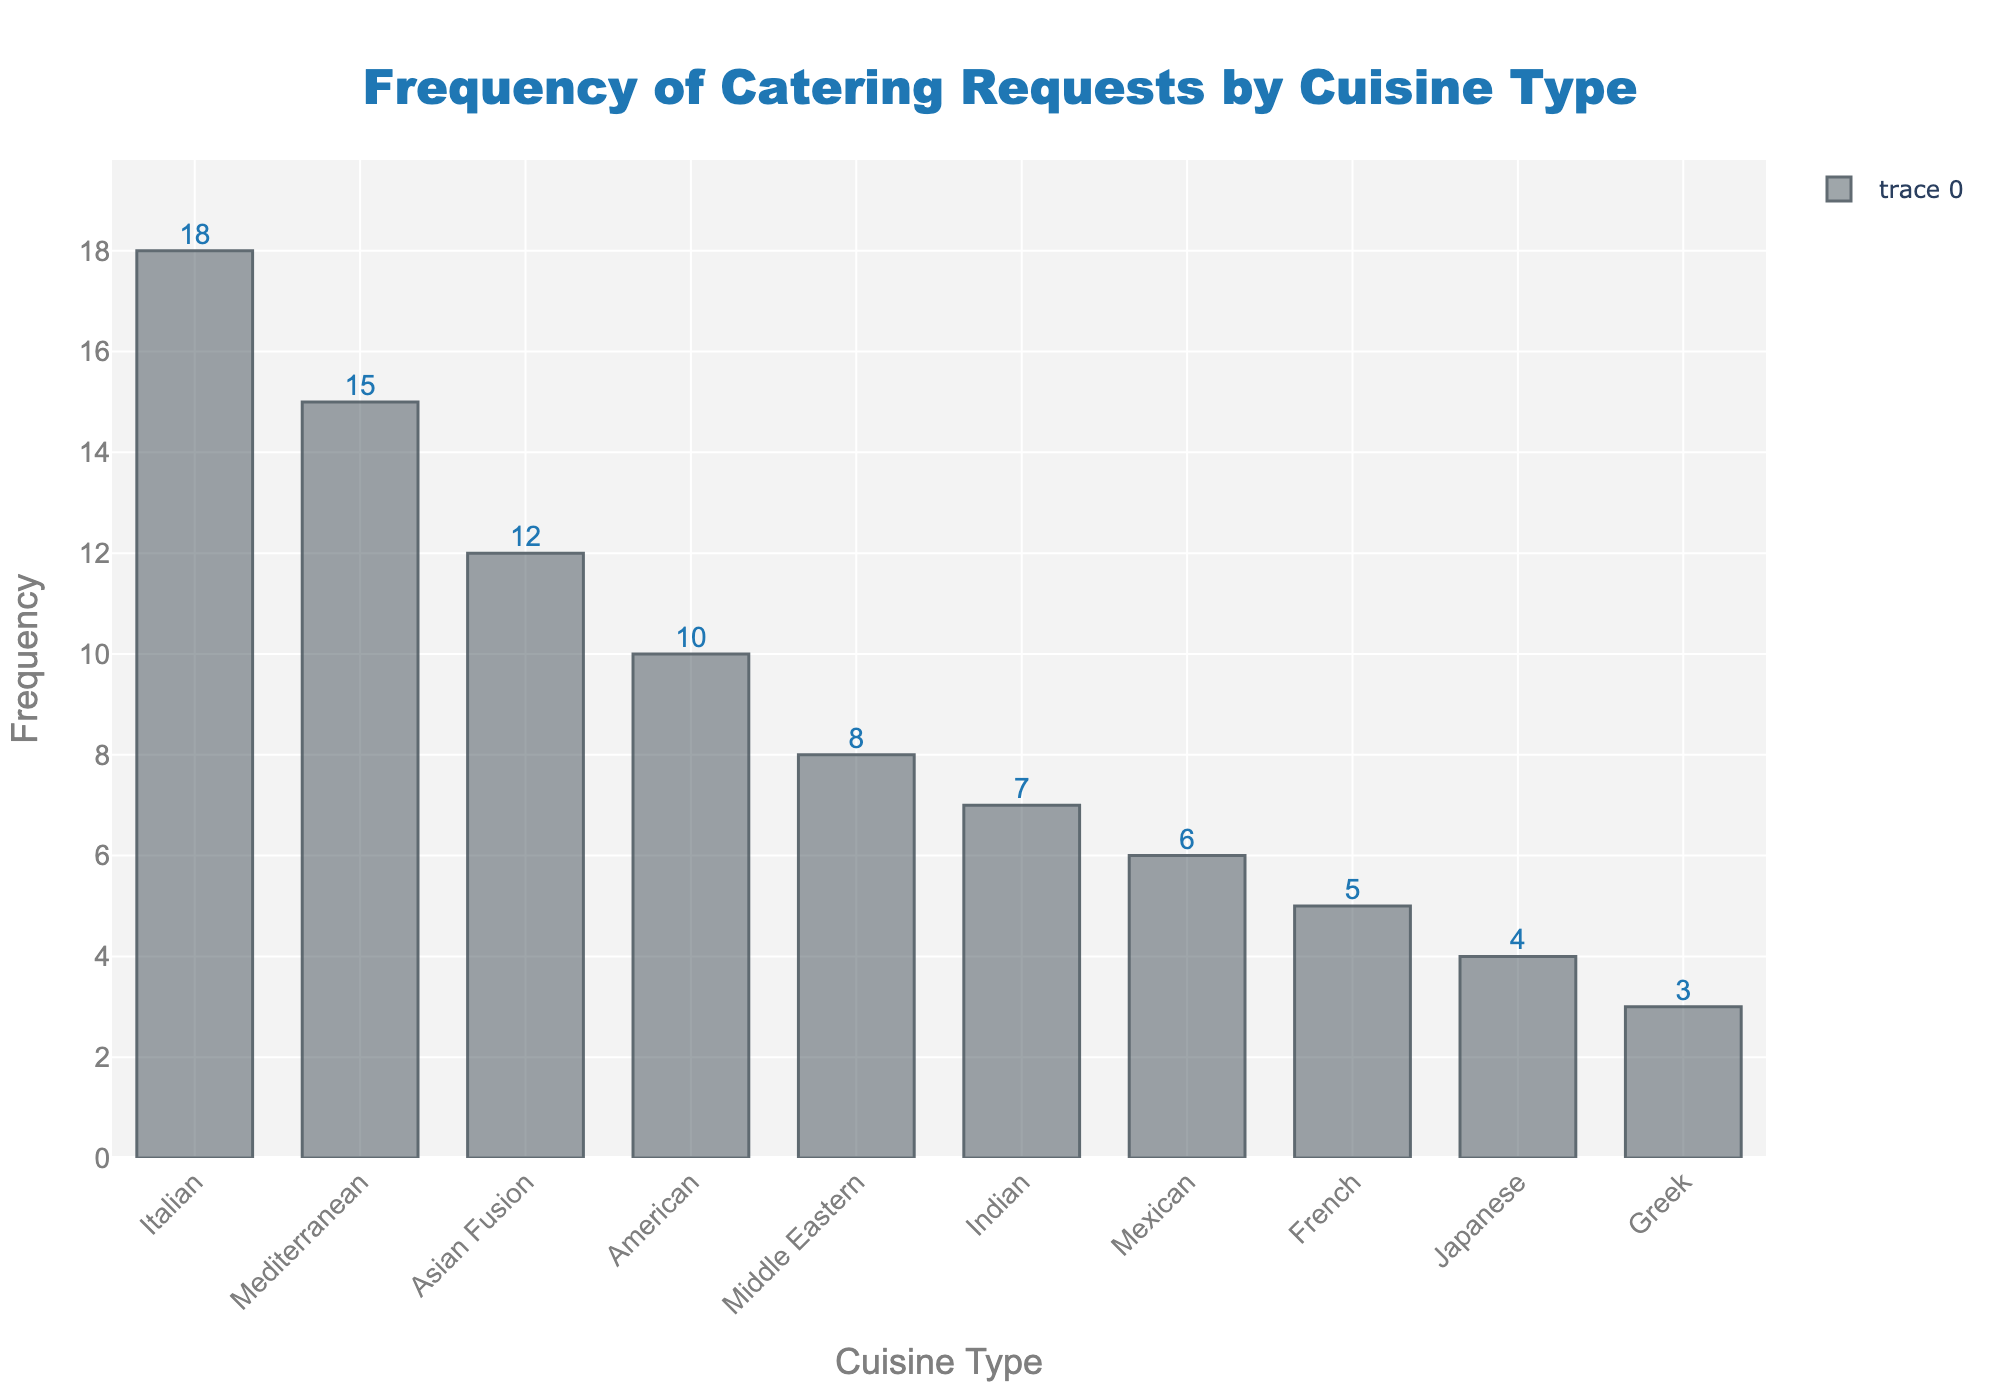What is the title of the figure? The title is at the top of the figure and reads "Frequency of Catering Requests by Cuisine Type."
Answer: Frequency of Catering Requests by Cuisine Type Which cuisine type has the highest frequency of catering requests? The highest bar represents the cuisine type with the most requests, which is "Italian" at 18 requests.
Answer: Italian What is the frequency of Mediterranean cuisine requests? The bar labeled "Mediterranean" shows a frequency of 15.
Answer: 15 How many cuisines have a frequency of 10 or more? The bars for Italian (18), Mediterranean (15), Asian Fusion (12), and American (10) exceed or equal 10, totaling 4 cuisines.
Answer: 4 What is the difference in frequency between the highest and lowest cuisine types? The highest frequency is Italian with 18 requests and the lowest is Greek with 3 requests. The difference is 18 - 3 = 15.
Answer: 15 How does the frequency of American cuisine compare to Indian cuisine? The bar for American shows a frequency of 10 whereas Indian shows 7. American has more requests than Indian by 10 - 7 = 3.
Answer: 3 What is the sum of requests for Asian Fusion and Japanese cuisines? Asian Fusion has a frequency of 12 and Japanese has 4. The sum is 12 + 4 = 16.
Answer: 16 Which cuisine types have fewer requests than Middle Eastern cuisine? Middle Eastern has a frequency of 8. The cuisine types with fewer requests are Indian (7), Mexican (6), French (5), Japanese (4), and Greek (3).
Answer: Indian, Mexican, French, Japanese, Greek What is the average frequency of catering requests across all the cuisine types? The frequencies are: 18, 15, 12, 10, 8, 7, 6, 5, 4, 3. Their sum is 88. There are 10 cuisines, so the average is 88 / 10 = 8.8.
Answer: 8.8 Which cuisine type lies in the middle when the frequencies are sorted in descending order? When sorted, the frequencies are: 18, 15, 12, 10, 8, 7, 6, 5, 4, 3. The middle value is the 5th and 6th values, 8 (Middle Eastern) and 7 (Indian). Taking the middle point, Middle Eastern is right above the median.
Answer: Middle Eastern 